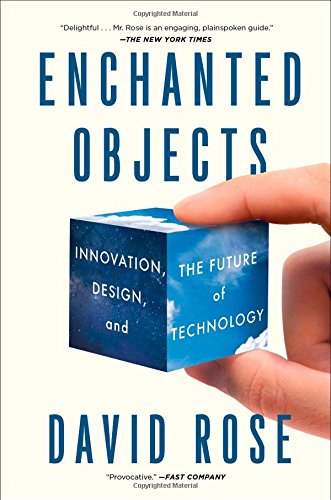Is this a journey related book? No, 'Enchanted Objects' is not centered on the theme of a journey, but rather it is a deep dive into the current and future roles of technology in our daily lives through the lens of object design. 